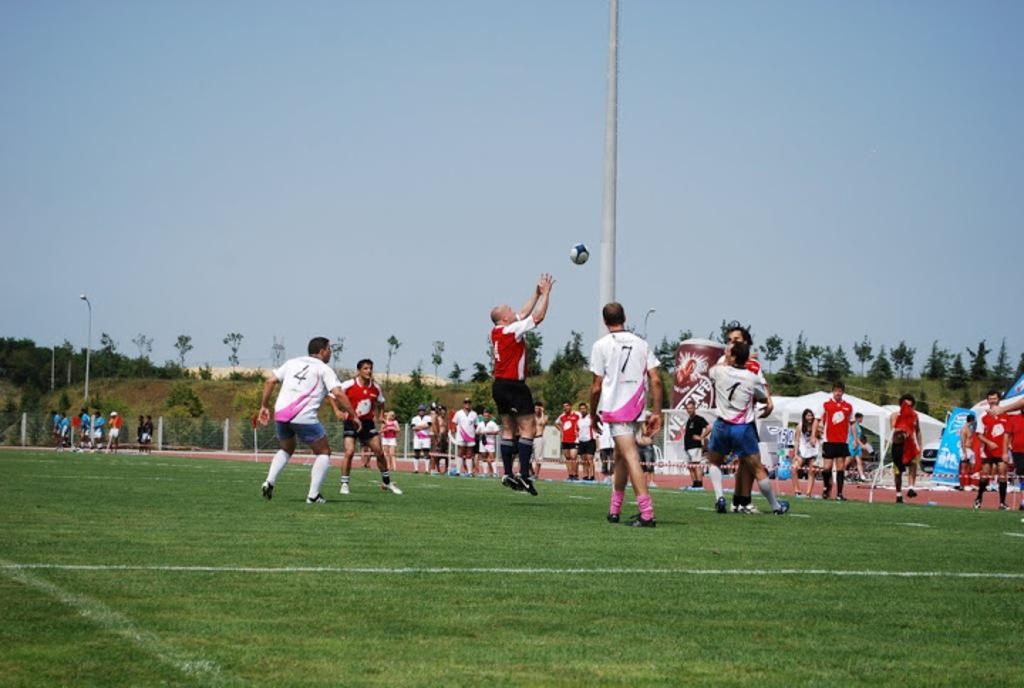Provide a one-sentence caption for the provided image. A soccer game between male players with jersey numbers 4, 7, 1, and more. 